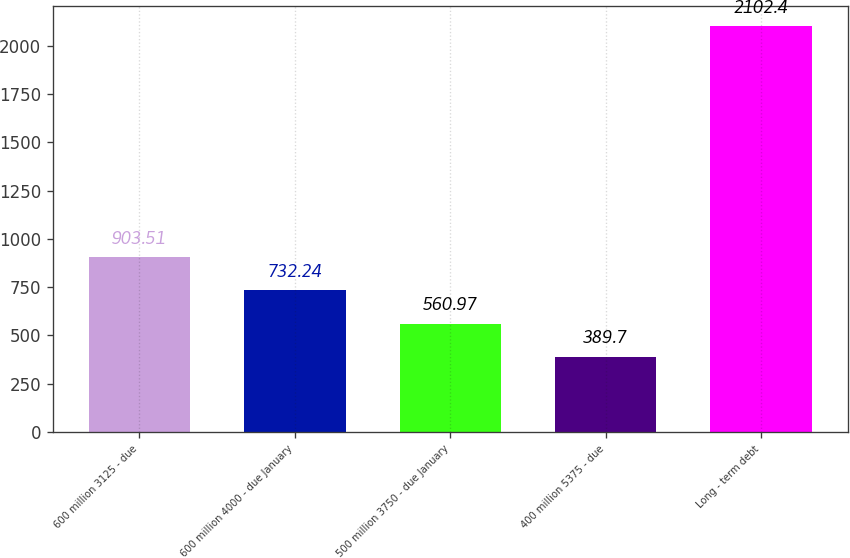Convert chart to OTSL. <chart><loc_0><loc_0><loc_500><loc_500><bar_chart><fcel>600 million 3125 - due<fcel>600 million 4000 - due January<fcel>500 million 3750 - due January<fcel>400 million 5375 - due<fcel>Long - term debt<nl><fcel>903.51<fcel>732.24<fcel>560.97<fcel>389.7<fcel>2102.4<nl></chart> 